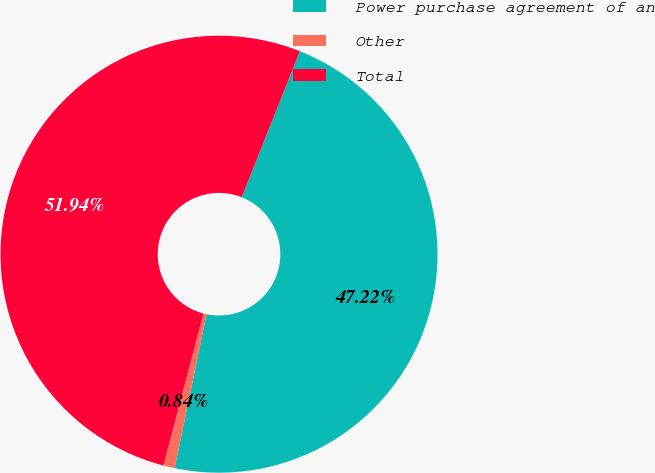<chart> <loc_0><loc_0><loc_500><loc_500><pie_chart><fcel>Power purchase agreement of an<fcel>Other<fcel>Total<nl><fcel>47.22%<fcel>0.84%<fcel>51.94%<nl></chart> 